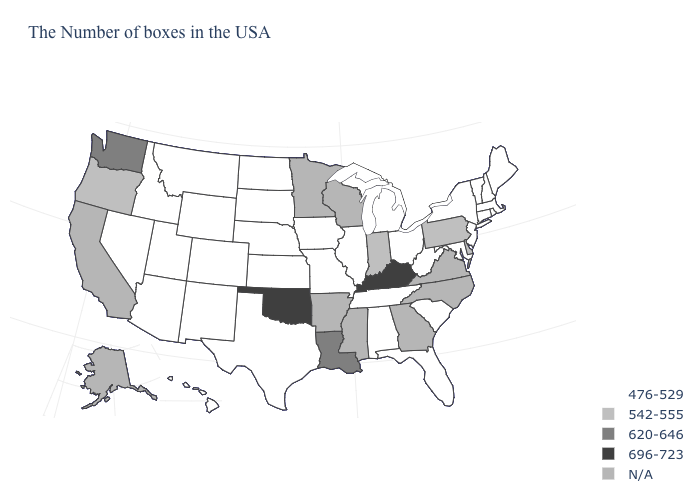What is the value of South Carolina?
Be succinct. 476-529. How many symbols are there in the legend?
Give a very brief answer. 5. Does the map have missing data?
Concise answer only. Yes. What is the lowest value in the South?
Concise answer only. 476-529. What is the value of Connecticut?
Keep it brief. 476-529. Which states have the lowest value in the MidWest?
Keep it brief. Ohio, Michigan, Illinois, Missouri, Iowa, Kansas, Nebraska, South Dakota, North Dakota. Which states have the lowest value in the USA?
Quick response, please. Maine, Massachusetts, Rhode Island, New Hampshire, Vermont, Connecticut, New York, New Jersey, Maryland, South Carolina, West Virginia, Ohio, Florida, Michigan, Alabama, Tennessee, Illinois, Missouri, Iowa, Kansas, Nebraska, Texas, South Dakota, North Dakota, Wyoming, Colorado, New Mexico, Utah, Montana, Arizona, Idaho, Nevada, Hawaii. Does the first symbol in the legend represent the smallest category?
Short answer required. Yes. Does South Dakota have the highest value in the USA?
Concise answer only. No. What is the value of Vermont?
Be succinct. 476-529. Among the states that border North Dakota , which have the lowest value?
Write a very short answer. South Dakota, Montana. What is the value of South Dakota?
Quick response, please. 476-529. What is the highest value in states that border Maine?
Be succinct. 476-529. Is the legend a continuous bar?
Answer briefly. No. 